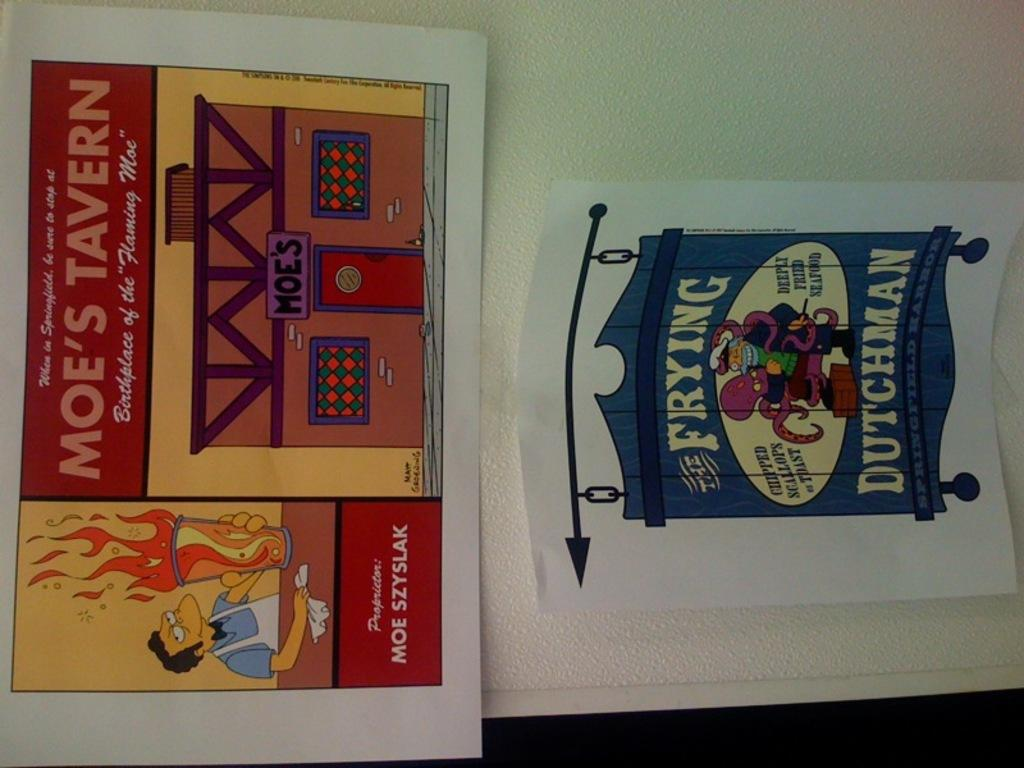<image>
Write a terse but informative summary of the picture. Signage for retail establishments like Moe's Tavern and Frying Dutchman. 